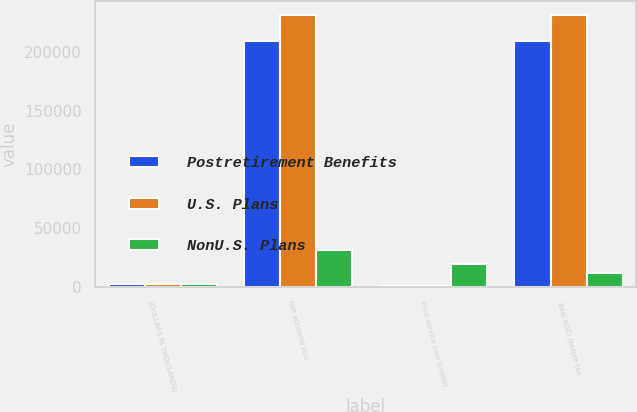<chart> <loc_0><loc_0><loc_500><loc_500><stacked_bar_chart><ecel><fcel>(DOLLARS IN THOUSANDS)<fcel>Net actuarial loss<fcel>Prior service cost (credit)<fcel>Total AOCI (before tax<nl><fcel>Postretirement Benefits<fcel>2012<fcel>209156<fcel>786<fcel>209942<nl><fcel>U.S. Plans<fcel>2012<fcel>231857<fcel>431<fcel>231426<nl><fcel>NonU.S. Plans<fcel>2012<fcel>31087<fcel>19719<fcel>11368<nl></chart> 